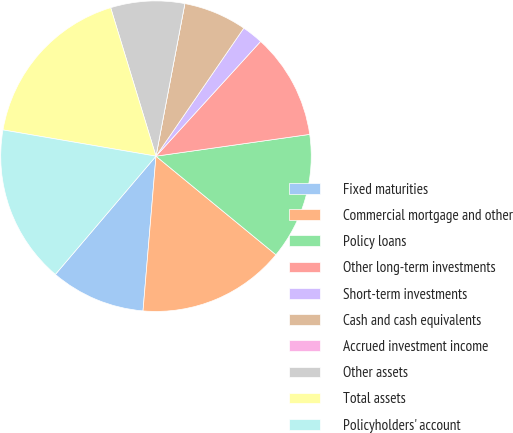Convert chart. <chart><loc_0><loc_0><loc_500><loc_500><pie_chart><fcel>Fixed maturities<fcel>Commercial mortgage and other<fcel>Policy loans<fcel>Other long-term investments<fcel>Short-term investments<fcel>Cash and cash equivalents<fcel>Accrued investment income<fcel>Other assets<fcel>Total assets<fcel>Policyholders' account<nl><fcel>9.89%<fcel>15.38%<fcel>13.19%<fcel>10.99%<fcel>2.2%<fcel>6.59%<fcel>0.0%<fcel>7.69%<fcel>17.58%<fcel>16.48%<nl></chart> 